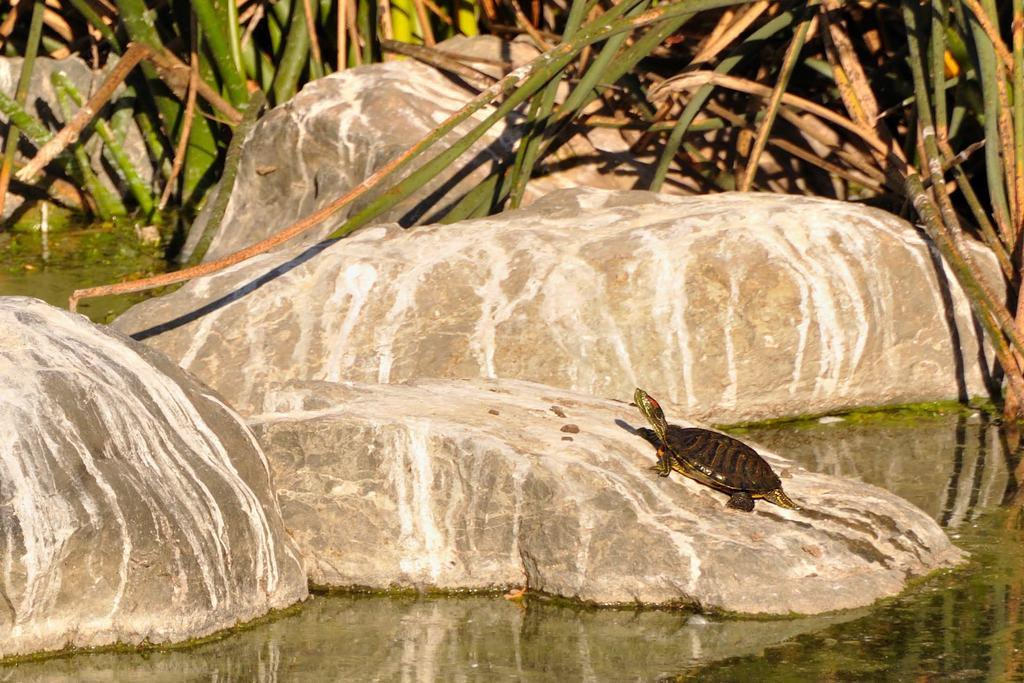What animal can be seen in the image? There is a tortoise on a rock in the image. What is the tortoise standing on? The tortoise is standing on a rock in the image. What can be seen in the background of the image? There are rocks and plants in the background of the image. What is visible at the bottom of the image? There is water visible at the bottom of the image. What type of eggnog is being served to the tortoise in the image? There is no eggnog present in the image; it features a tortoise on a rock with a background of rocks, plants, and water. 